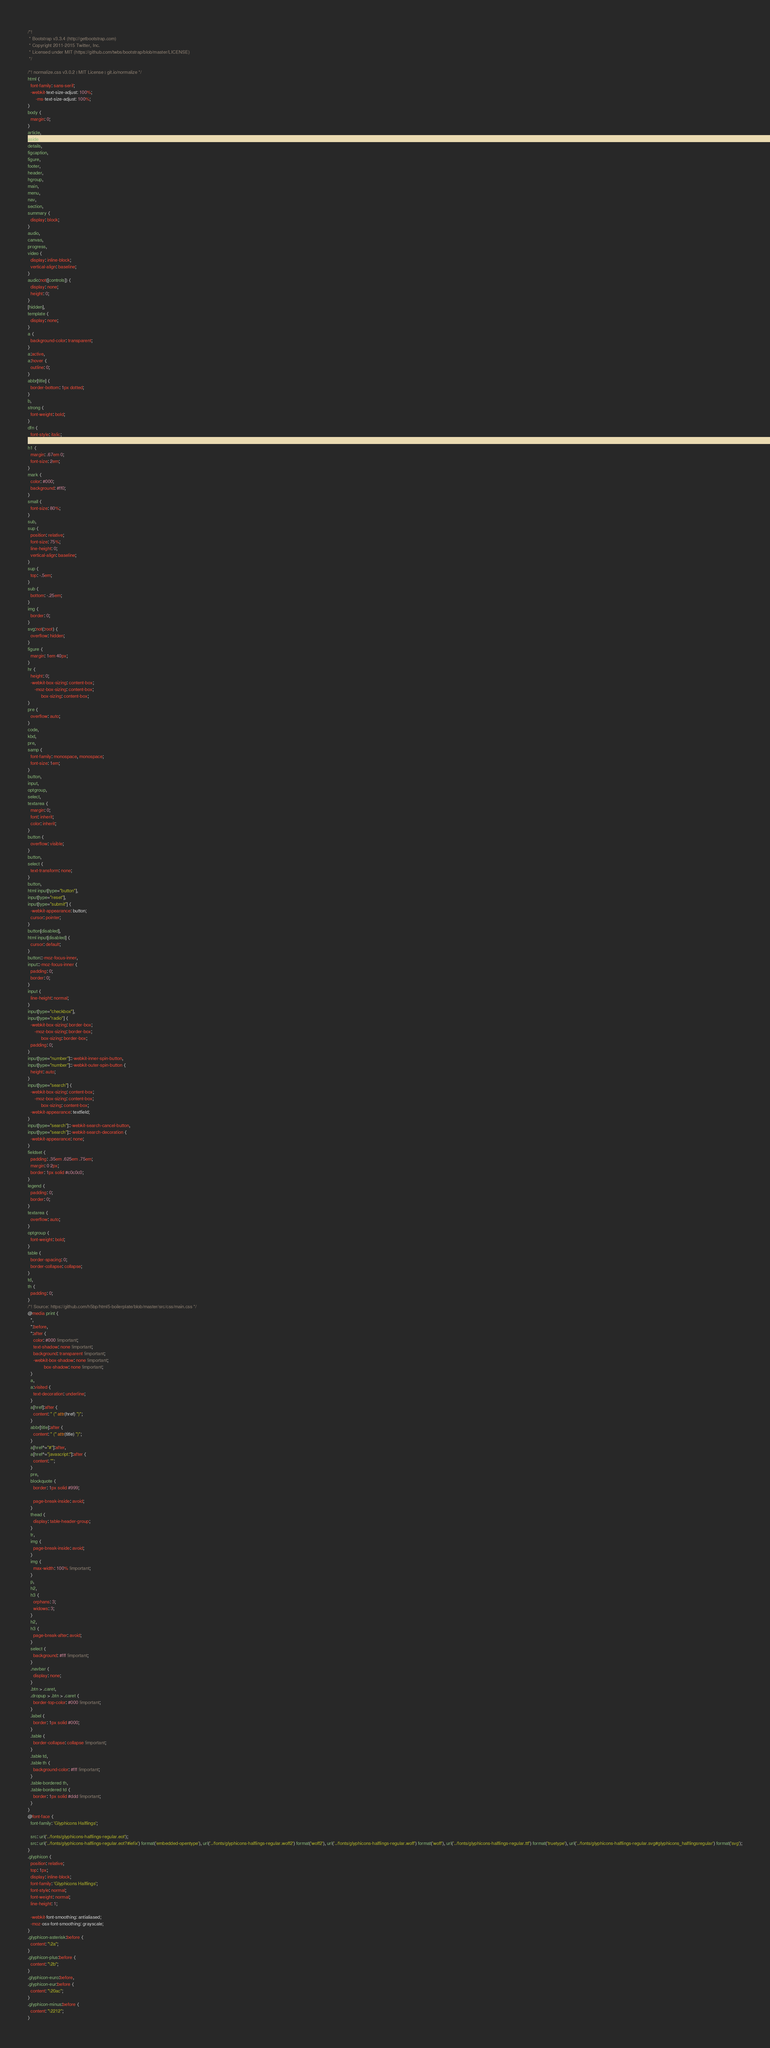Convert code to text. <code><loc_0><loc_0><loc_500><loc_500><_CSS_>/*!
 * Bootstrap v3.3.4 (http://getbootstrap.com)
 * Copyright 2011-2015 Twitter, Inc.
 * Licensed under MIT (https://github.com/twbs/bootstrap/blob/master/LICENSE)
 */

/*! normalize.css v3.0.2 | MIT License | git.io/normalize */
html {
  font-family: sans-serif;
  -webkit-text-size-adjust: 100%;
      -ms-text-size-adjust: 100%;
}
body {
  margin: 0;
}
article,
aside,
details,
figcaption,
figure,
footer,
header,
hgroup,
main,
menu,
nav,
section,
summary {
  display: block;
}
audio,
canvas,
progress,
video {
  display: inline-block;
  vertical-align: baseline;
}
audio:not([controls]) {
  display: none;
  height: 0;
}
[hidden],
template {
  display: none;
}
a {
  background-color: transparent;
}
a:active,
a:hover {
  outline: 0;
}
abbr[title] {
  border-bottom: 1px dotted;
}
b,
strong {
  font-weight: bold;
}
dfn {
  font-style: italic;
}
h1 {
  margin: .67em 0;
  font-size: 2em;
}
mark {
  color: #000;
  background: #ff0;
}
small {
  font-size: 80%;
}
sub,
sup {
  position: relative;
  font-size: 75%;
  line-height: 0;
  vertical-align: baseline;
}
sup {
  top: -.5em;
}
sub {
  bottom: -.25em;
}
img {
  border: 0;
}
svg:not(:root) {
  overflow: hidden;
}
figure {
  margin: 1em 40px;
}
hr {
  height: 0;
  -webkit-box-sizing: content-box;
     -moz-box-sizing: content-box;
          box-sizing: content-box;
}
pre {
  overflow: auto;
}
code,
kbd,
pre,
samp {
  font-family: monospace, monospace;
  font-size: 1em;
}
button,
input,
optgroup,
select,
textarea {
  margin: 0;
  font: inherit;
  color: inherit;
}
button {
  overflow: visible;
}
button,
select {
  text-transform: none;
}
button,
html input[type="button"],
input[type="reset"],
input[type="submit"] {
  -webkit-appearance: button;
  cursor: pointer;
}
button[disabled],
html input[disabled] {
  cursor: default;
}
button::-moz-focus-inner,
input::-moz-focus-inner {
  padding: 0;
  border: 0;
}
input {
  line-height: normal;
}
input[type="checkbox"],
input[type="radio"] {
  -webkit-box-sizing: border-box;
     -moz-box-sizing: border-box;
          box-sizing: border-box;
  padding: 0;
}
input[type="number"]::-webkit-inner-spin-button,
input[type="number"]::-webkit-outer-spin-button {
  height: auto;
}
input[type="search"] {
  -webkit-box-sizing: content-box;
     -moz-box-sizing: content-box;
          box-sizing: content-box;
  -webkit-appearance: textfield;
}
input[type="search"]::-webkit-search-cancel-button,
input[type="search"]::-webkit-search-decoration {
  -webkit-appearance: none;
}
fieldset {
  padding: .35em .625em .75em;
  margin: 0 2px;
  border: 1px solid #c0c0c0;
}
legend {
  padding: 0;
  border: 0;
}
textarea {
  overflow: auto;
}
optgroup {
  font-weight: bold;
}
table {
  border-spacing: 0;
  border-collapse: collapse;
}
td,
th {
  padding: 0;
}
/*! Source: https://github.com/h5bp/html5-boilerplate/blob/master/src/css/main.css */
@media print {
  *,
  *:before,
  *:after {
    color: #000 !important;
    text-shadow: none !important;
    background: transparent !important;
    -webkit-box-shadow: none !important;
            box-shadow: none !important;
  }
  a,
  a:visited {
    text-decoration: underline;
  }
  a[href]:after {
    content: " (" attr(href) ")";
  }
  abbr[title]:after {
    content: " (" attr(title) ")";
  }
  a[href^="#"]:after,
  a[href^="javascript:"]:after {
    content: "";
  }
  pre,
  blockquote {
    border: 1px solid #999;

    page-break-inside: avoid;
  }
  thead {
    display: table-header-group;
  }
  tr,
  img {
    page-break-inside: avoid;
  }
  img {
    max-width: 100% !important;
  }
  p,
  h2,
  h3 {
    orphans: 3;
    widows: 3;
  }
  h2,
  h3 {
    page-break-after: avoid;
  }
  select {
    background: #fff !important;
  }
  .navbar {
    display: none;
  }
  .btn > .caret,
  .dropup > .btn > .caret {
    border-top-color: #000 !important;
  }
  .label {
    border: 1px solid #000;
  }
  .table {
    border-collapse: collapse !important;
  }
  .table td,
  .table th {
    background-color: #fff !important;
  }
  .table-bordered th,
  .table-bordered td {
    border: 1px solid #ddd !important;
  }
}
@font-face {
  font-family: 'Glyphicons Halflings';

  src: url('../fonts/glyphicons-halflings-regular.eot');
  src: url('../fonts/glyphicons-halflings-regular.eot?#iefix') format('embedded-opentype'), url('../fonts/glyphicons-halflings-regular.woff2') format('woff2'), url('../fonts/glyphicons-halflings-regular.woff') format('woff'), url('../fonts/glyphicons-halflings-regular.ttf') format('truetype'), url('../fonts/glyphicons-halflings-regular.svg#glyphicons_halflingsregular') format('svg');
}
.glyphicon {
  position: relative;
  top: 1px;
  display: inline-block;
  font-family: 'Glyphicons Halflings';
  font-style: normal;
  font-weight: normal;
  line-height: 1;

  -webkit-font-smoothing: antialiased;
  -moz-osx-font-smoothing: grayscale;
}
.glyphicon-asterisk:before {
  content: "\2a";
}
.glyphicon-plus:before {
  content: "\2b";
}
.glyphicon-euro:before,
.glyphicon-eur:before {
  content: "\20ac";
}
.glyphicon-minus:before {
  content: "\2212";
}</code> 